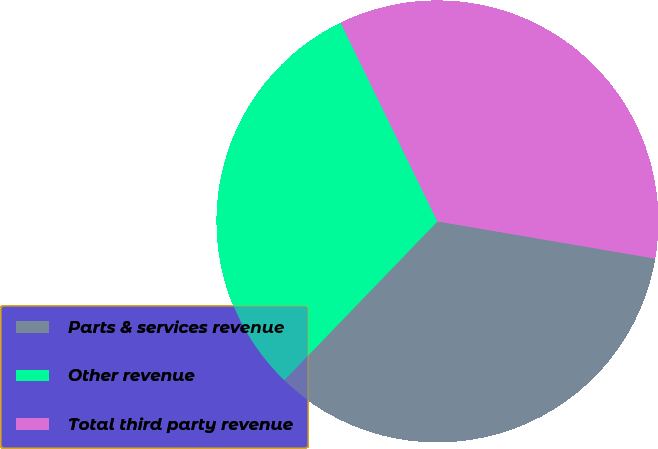<chart> <loc_0><loc_0><loc_500><loc_500><pie_chart><fcel>Parts & services revenue<fcel>Other revenue<fcel>Total third party revenue<nl><fcel>34.51%<fcel>30.58%<fcel>34.91%<nl></chart> 